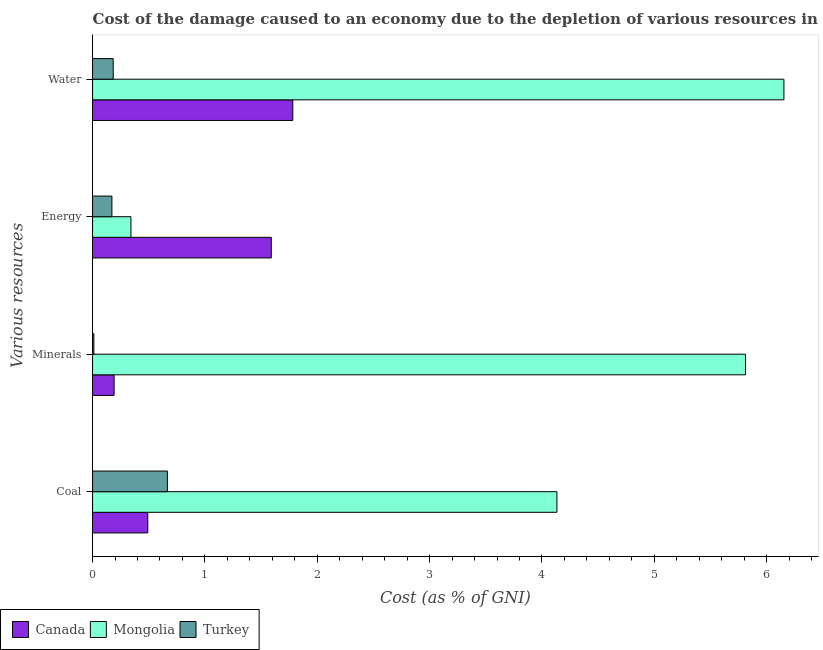How many bars are there on the 3rd tick from the bottom?
Provide a succinct answer. 3. What is the label of the 1st group of bars from the top?
Ensure brevity in your answer.  Water. What is the cost of damage due to depletion of minerals in Turkey?
Your answer should be compact. 0.01. Across all countries, what is the maximum cost of damage due to depletion of coal?
Keep it short and to the point. 4.13. Across all countries, what is the minimum cost of damage due to depletion of minerals?
Your answer should be very brief. 0.01. In which country was the cost of damage due to depletion of coal maximum?
Offer a terse response. Mongolia. In which country was the cost of damage due to depletion of coal minimum?
Your response must be concise. Canada. What is the total cost of damage due to depletion of energy in the graph?
Offer a terse response. 2.1. What is the difference between the cost of damage due to depletion of coal in Canada and that in Turkey?
Provide a succinct answer. -0.17. What is the difference between the cost of damage due to depletion of energy in Canada and the cost of damage due to depletion of water in Mongolia?
Offer a very short reply. -4.56. What is the average cost of damage due to depletion of coal per country?
Make the answer very short. 1.76. What is the difference between the cost of damage due to depletion of water and cost of damage due to depletion of coal in Mongolia?
Provide a succinct answer. 2.02. In how many countries, is the cost of damage due to depletion of water greater than 0.8 %?
Make the answer very short. 2. What is the ratio of the cost of damage due to depletion of minerals in Mongolia to that in Turkey?
Provide a short and direct response. 504.31. Is the cost of damage due to depletion of water in Mongolia less than that in Canada?
Make the answer very short. No. What is the difference between the highest and the second highest cost of damage due to depletion of minerals?
Your response must be concise. 5.62. What is the difference between the highest and the lowest cost of damage due to depletion of energy?
Offer a very short reply. 1.42. In how many countries, is the cost of damage due to depletion of water greater than the average cost of damage due to depletion of water taken over all countries?
Your answer should be compact. 1. What does the 2nd bar from the top in Coal represents?
Provide a short and direct response. Mongolia. What does the 3rd bar from the bottom in Minerals represents?
Ensure brevity in your answer.  Turkey. How many bars are there?
Provide a short and direct response. 12. What is the difference between two consecutive major ticks on the X-axis?
Provide a succinct answer. 1. Does the graph contain grids?
Provide a short and direct response. No. Where does the legend appear in the graph?
Offer a very short reply. Bottom left. How are the legend labels stacked?
Provide a succinct answer. Horizontal. What is the title of the graph?
Keep it short and to the point. Cost of the damage caused to an economy due to the depletion of various resources in 1997 . Does "European Union" appear as one of the legend labels in the graph?
Your answer should be very brief. No. What is the label or title of the X-axis?
Give a very brief answer. Cost (as % of GNI). What is the label or title of the Y-axis?
Provide a succinct answer. Various resources. What is the Cost (as % of GNI) of Canada in Coal?
Your response must be concise. 0.49. What is the Cost (as % of GNI) in Mongolia in Coal?
Offer a terse response. 4.13. What is the Cost (as % of GNI) of Turkey in Coal?
Your response must be concise. 0.67. What is the Cost (as % of GNI) of Canada in Minerals?
Offer a terse response. 0.19. What is the Cost (as % of GNI) in Mongolia in Minerals?
Provide a succinct answer. 5.81. What is the Cost (as % of GNI) in Turkey in Minerals?
Your response must be concise. 0.01. What is the Cost (as % of GNI) of Canada in Energy?
Offer a terse response. 1.59. What is the Cost (as % of GNI) in Mongolia in Energy?
Provide a short and direct response. 0.34. What is the Cost (as % of GNI) of Turkey in Energy?
Your answer should be very brief. 0.17. What is the Cost (as % of GNI) of Canada in Water?
Make the answer very short. 1.78. What is the Cost (as % of GNI) of Mongolia in Water?
Your answer should be very brief. 6.15. What is the Cost (as % of GNI) of Turkey in Water?
Make the answer very short. 0.18. Across all Various resources, what is the maximum Cost (as % of GNI) in Canada?
Your answer should be very brief. 1.78. Across all Various resources, what is the maximum Cost (as % of GNI) of Mongolia?
Keep it short and to the point. 6.15. Across all Various resources, what is the maximum Cost (as % of GNI) in Turkey?
Provide a succinct answer. 0.67. Across all Various resources, what is the minimum Cost (as % of GNI) in Canada?
Offer a very short reply. 0.19. Across all Various resources, what is the minimum Cost (as % of GNI) in Mongolia?
Ensure brevity in your answer.  0.34. Across all Various resources, what is the minimum Cost (as % of GNI) in Turkey?
Ensure brevity in your answer.  0.01. What is the total Cost (as % of GNI) in Canada in the graph?
Your answer should be very brief. 4.06. What is the total Cost (as % of GNI) of Mongolia in the graph?
Your answer should be compact. 16.44. What is the total Cost (as % of GNI) of Turkey in the graph?
Provide a short and direct response. 1.03. What is the difference between the Cost (as % of GNI) of Canada in Coal and that in Minerals?
Provide a succinct answer. 0.3. What is the difference between the Cost (as % of GNI) in Mongolia in Coal and that in Minerals?
Offer a very short reply. -1.68. What is the difference between the Cost (as % of GNI) in Turkey in Coal and that in Minerals?
Make the answer very short. 0.65. What is the difference between the Cost (as % of GNI) of Canada in Coal and that in Energy?
Provide a succinct answer. -1.1. What is the difference between the Cost (as % of GNI) of Mongolia in Coal and that in Energy?
Provide a succinct answer. 3.79. What is the difference between the Cost (as % of GNI) in Turkey in Coal and that in Energy?
Make the answer very short. 0.49. What is the difference between the Cost (as % of GNI) in Canada in Coal and that in Water?
Give a very brief answer. -1.29. What is the difference between the Cost (as % of GNI) of Mongolia in Coal and that in Water?
Keep it short and to the point. -2.02. What is the difference between the Cost (as % of GNI) in Turkey in Coal and that in Water?
Give a very brief answer. 0.48. What is the difference between the Cost (as % of GNI) of Canada in Minerals and that in Energy?
Your answer should be compact. -1.4. What is the difference between the Cost (as % of GNI) in Mongolia in Minerals and that in Energy?
Your answer should be compact. 5.47. What is the difference between the Cost (as % of GNI) in Turkey in Minerals and that in Energy?
Offer a very short reply. -0.16. What is the difference between the Cost (as % of GNI) in Canada in Minerals and that in Water?
Provide a short and direct response. -1.59. What is the difference between the Cost (as % of GNI) of Mongolia in Minerals and that in Water?
Make the answer very short. -0.34. What is the difference between the Cost (as % of GNI) of Turkey in Minerals and that in Water?
Your response must be concise. -0.17. What is the difference between the Cost (as % of GNI) of Canada in Energy and that in Water?
Your answer should be very brief. -0.19. What is the difference between the Cost (as % of GNI) in Mongolia in Energy and that in Water?
Ensure brevity in your answer.  -5.81. What is the difference between the Cost (as % of GNI) in Turkey in Energy and that in Water?
Ensure brevity in your answer.  -0.01. What is the difference between the Cost (as % of GNI) in Canada in Coal and the Cost (as % of GNI) in Mongolia in Minerals?
Your answer should be compact. -5.32. What is the difference between the Cost (as % of GNI) of Canada in Coal and the Cost (as % of GNI) of Turkey in Minerals?
Your response must be concise. 0.48. What is the difference between the Cost (as % of GNI) in Mongolia in Coal and the Cost (as % of GNI) in Turkey in Minerals?
Offer a terse response. 4.12. What is the difference between the Cost (as % of GNI) of Canada in Coal and the Cost (as % of GNI) of Mongolia in Energy?
Your answer should be compact. 0.15. What is the difference between the Cost (as % of GNI) of Canada in Coal and the Cost (as % of GNI) of Turkey in Energy?
Your response must be concise. 0.32. What is the difference between the Cost (as % of GNI) in Mongolia in Coal and the Cost (as % of GNI) in Turkey in Energy?
Keep it short and to the point. 3.96. What is the difference between the Cost (as % of GNI) of Canada in Coal and the Cost (as % of GNI) of Mongolia in Water?
Offer a very short reply. -5.66. What is the difference between the Cost (as % of GNI) in Canada in Coal and the Cost (as % of GNI) in Turkey in Water?
Ensure brevity in your answer.  0.31. What is the difference between the Cost (as % of GNI) of Mongolia in Coal and the Cost (as % of GNI) of Turkey in Water?
Your answer should be compact. 3.95. What is the difference between the Cost (as % of GNI) in Canada in Minerals and the Cost (as % of GNI) in Mongolia in Energy?
Provide a short and direct response. -0.15. What is the difference between the Cost (as % of GNI) in Canada in Minerals and the Cost (as % of GNI) in Turkey in Energy?
Ensure brevity in your answer.  0.02. What is the difference between the Cost (as % of GNI) in Mongolia in Minerals and the Cost (as % of GNI) in Turkey in Energy?
Offer a very short reply. 5.64. What is the difference between the Cost (as % of GNI) in Canada in Minerals and the Cost (as % of GNI) in Mongolia in Water?
Offer a terse response. -5.96. What is the difference between the Cost (as % of GNI) of Canada in Minerals and the Cost (as % of GNI) of Turkey in Water?
Provide a short and direct response. 0.01. What is the difference between the Cost (as % of GNI) in Mongolia in Minerals and the Cost (as % of GNI) in Turkey in Water?
Offer a terse response. 5.63. What is the difference between the Cost (as % of GNI) of Canada in Energy and the Cost (as % of GNI) of Mongolia in Water?
Offer a very short reply. -4.56. What is the difference between the Cost (as % of GNI) of Canada in Energy and the Cost (as % of GNI) of Turkey in Water?
Provide a short and direct response. 1.41. What is the difference between the Cost (as % of GNI) in Mongolia in Energy and the Cost (as % of GNI) in Turkey in Water?
Your answer should be compact. 0.16. What is the average Cost (as % of GNI) in Canada per Various resources?
Offer a terse response. 1.01. What is the average Cost (as % of GNI) of Mongolia per Various resources?
Your answer should be very brief. 4.11. What is the average Cost (as % of GNI) of Turkey per Various resources?
Keep it short and to the point. 0.26. What is the difference between the Cost (as % of GNI) in Canada and Cost (as % of GNI) in Mongolia in Coal?
Your answer should be very brief. -3.64. What is the difference between the Cost (as % of GNI) in Canada and Cost (as % of GNI) in Turkey in Coal?
Provide a succinct answer. -0.17. What is the difference between the Cost (as % of GNI) in Mongolia and Cost (as % of GNI) in Turkey in Coal?
Offer a terse response. 3.47. What is the difference between the Cost (as % of GNI) in Canada and Cost (as % of GNI) in Mongolia in Minerals?
Provide a succinct answer. -5.62. What is the difference between the Cost (as % of GNI) of Canada and Cost (as % of GNI) of Turkey in Minerals?
Your response must be concise. 0.18. What is the difference between the Cost (as % of GNI) of Mongolia and Cost (as % of GNI) of Turkey in Minerals?
Make the answer very short. 5.8. What is the difference between the Cost (as % of GNI) of Canada and Cost (as % of GNI) of Mongolia in Energy?
Ensure brevity in your answer.  1.25. What is the difference between the Cost (as % of GNI) in Canada and Cost (as % of GNI) in Turkey in Energy?
Ensure brevity in your answer.  1.42. What is the difference between the Cost (as % of GNI) of Mongolia and Cost (as % of GNI) of Turkey in Energy?
Provide a succinct answer. 0.17. What is the difference between the Cost (as % of GNI) in Canada and Cost (as % of GNI) in Mongolia in Water?
Give a very brief answer. -4.37. What is the difference between the Cost (as % of GNI) in Canada and Cost (as % of GNI) in Turkey in Water?
Your answer should be very brief. 1.6. What is the difference between the Cost (as % of GNI) in Mongolia and Cost (as % of GNI) in Turkey in Water?
Provide a short and direct response. 5.97. What is the ratio of the Cost (as % of GNI) in Canada in Coal to that in Minerals?
Provide a short and direct response. 2.56. What is the ratio of the Cost (as % of GNI) in Mongolia in Coal to that in Minerals?
Your response must be concise. 0.71. What is the ratio of the Cost (as % of GNI) of Turkey in Coal to that in Minerals?
Offer a very short reply. 57.77. What is the ratio of the Cost (as % of GNI) in Canada in Coal to that in Energy?
Keep it short and to the point. 0.31. What is the ratio of the Cost (as % of GNI) in Mongolia in Coal to that in Energy?
Your answer should be compact. 12.1. What is the ratio of the Cost (as % of GNI) in Turkey in Coal to that in Energy?
Give a very brief answer. 3.87. What is the ratio of the Cost (as % of GNI) of Canada in Coal to that in Water?
Ensure brevity in your answer.  0.28. What is the ratio of the Cost (as % of GNI) of Mongolia in Coal to that in Water?
Offer a very short reply. 0.67. What is the ratio of the Cost (as % of GNI) in Turkey in Coal to that in Water?
Your answer should be very brief. 3.62. What is the ratio of the Cost (as % of GNI) of Canada in Minerals to that in Energy?
Your answer should be very brief. 0.12. What is the ratio of the Cost (as % of GNI) of Mongolia in Minerals to that in Energy?
Offer a very short reply. 17.01. What is the ratio of the Cost (as % of GNI) in Turkey in Minerals to that in Energy?
Offer a very short reply. 0.07. What is the ratio of the Cost (as % of GNI) of Canada in Minerals to that in Water?
Your response must be concise. 0.11. What is the ratio of the Cost (as % of GNI) of Mongolia in Minerals to that in Water?
Keep it short and to the point. 0.94. What is the ratio of the Cost (as % of GNI) of Turkey in Minerals to that in Water?
Your answer should be compact. 0.06. What is the ratio of the Cost (as % of GNI) of Canada in Energy to that in Water?
Your answer should be compact. 0.89. What is the ratio of the Cost (as % of GNI) of Mongolia in Energy to that in Water?
Offer a terse response. 0.06. What is the ratio of the Cost (as % of GNI) of Turkey in Energy to that in Water?
Give a very brief answer. 0.94. What is the difference between the highest and the second highest Cost (as % of GNI) of Canada?
Make the answer very short. 0.19. What is the difference between the highest and the second highest Cost (as % of GNI) of Mongolia?
Keep it short and to the point. 0.34. What is the difference between the highest and the second highest Cost (as % of GNI) of Turkey?
Your response must be concise. 0.48. What is the difference between the highest and the lowest Cost (as % of GNI) in Canada?
Provide a succinct answer. 1.59. What is the difference between the highest and the lowest Cost (as % of GNI) of Mongolia?
Your answer should be compact. 5.81. What is the difference between the highest and the lowest Cost (as % of GNI) of Turkey?
Offer a very short reply. 0.65. 